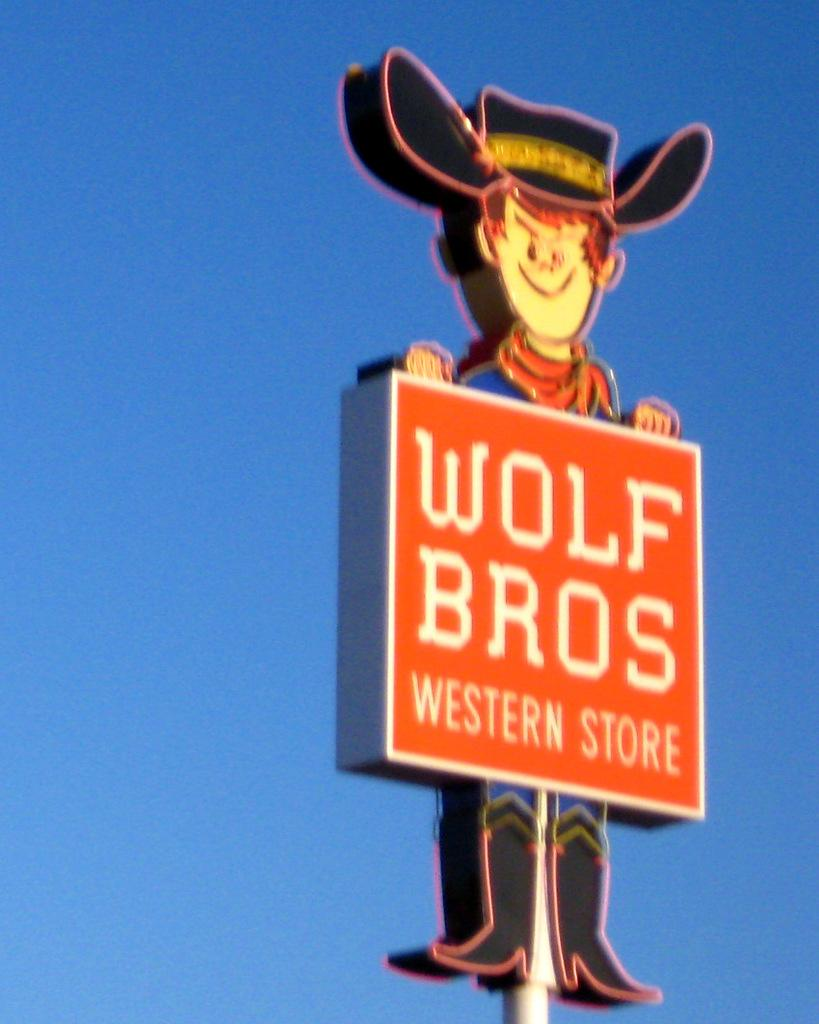What is the main object in the image? There is a sign board in the image. What type of store does the sign board advertise? The sign board is for a "Wolf Brothers Western Store." What type of care is provided for the wolves at the store? There are no wolves present at the store; it is a "Wolf Brothers Western Store," which likely refers to a store selling western clothing and accessories. 